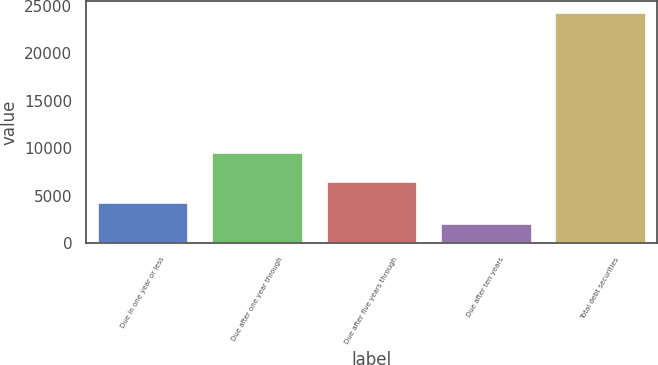Convert chart. <chart><loc_0><loc_0><loc_500><loc_500><bar_chart><fcel>Due in one year or less<fcel>Due after one year through<fcel>Due after five years through<fcel>Due after ten years<fcel>Total debt securities<nl><fcel>4334.7<fcel>9646<fcel>6556.4<fcel>2113<fcel>24330<nl></chart> 